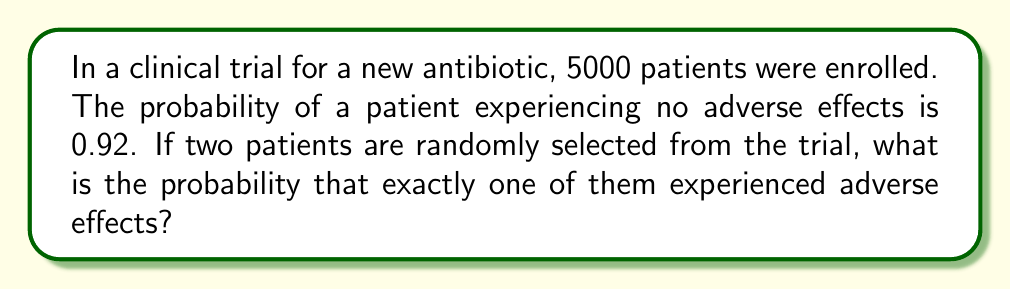Can you solve this math problem? Let's approach this step-by-step:

1) First, we need to calculate the probability of a patient experiencing adverse effects. If the probability of no adverse effects is 0.92, then:

   $P(\text{adverse effects}) = 1 - P(\text{no adverse effects}) = 1 - 0.92 = 0.08$

2) Now, we're dealing with a scenario where we want exactly one out of two patients to have experienced adverse effects. This can happen in two ways:
   - First patient has adverse effects, second doesn't
   - First patient doesn't have adverse effects, second does

3) We can use the multiplication rule of probability for each of these scenarios:

   $P(\text{first yes, second no}) = 0.08 \times 0.92$
   $P(\text{first no, second yes}) = 0.92 \times 0.08$

4) Since we want the probability of either of these scenarios occurring, we add their probabilities:

   $P(\text{exactly one with adverse effects}) = (0.08 \times 0.92) + (0.92 \times 0.08)$

5) Let's calculate:

   $P(\text{exactly one with adverse effects}) = 0.0736 + 0.0736 = 0.1472$

6) Therefore, the probability is 0.1472 or 14.72%.
Answer: 0.1472 